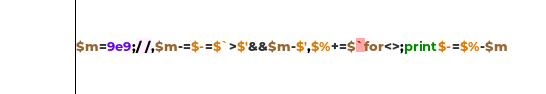<code> <loc_0><loc_0><loc_500><loc_500><_Perl_>$m=9e9;/ /,$m-=$-=$`>$'&&$m-$',$%+=$`for<>;print$-=$%-$m</code> 